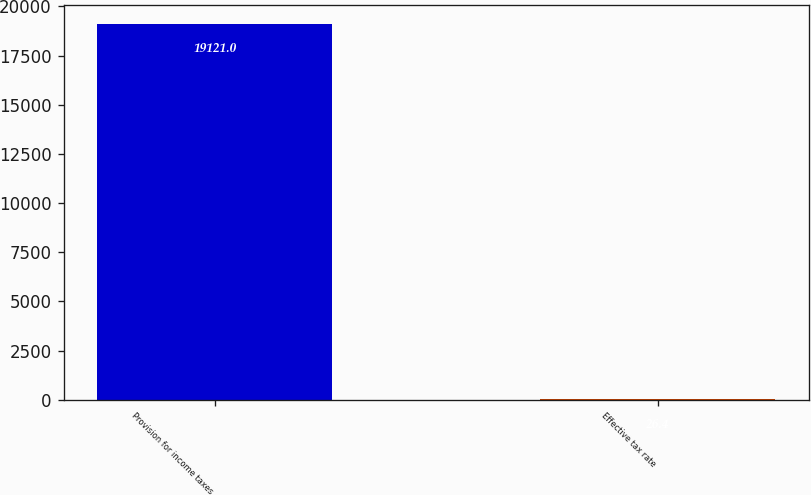<chart> <loc_0><loc_0><loc_500><loc_500><bar_chart><fcel>Provision for income taxes<fcel>Effective tax rate<nl><fcel>19121<fcel>26.4<nl></chart> 